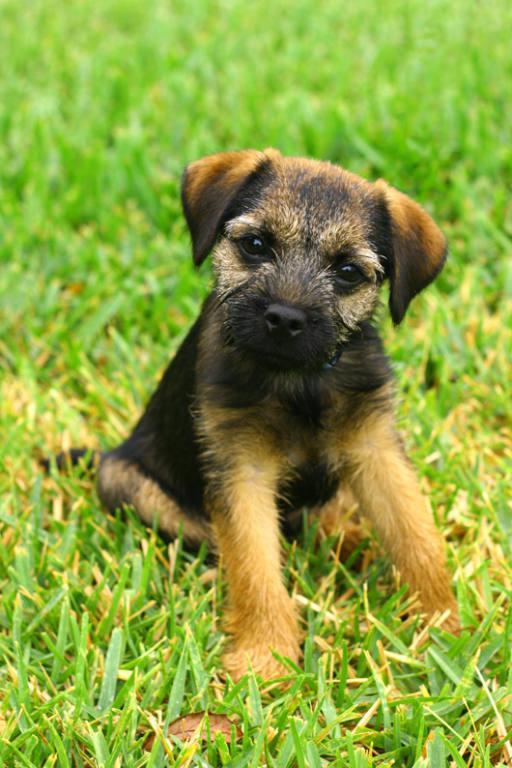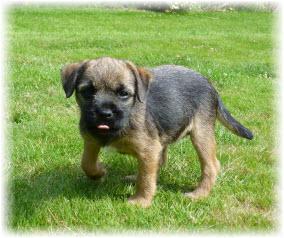The first image is the image on the left, the second image is the image on the right. For the images displayed, is the sentence "A puppy runs in the grass toward the photographer." factually correct? Answer yes or no. No. 